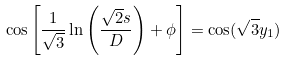Convert formula to latex. <formula><loc_0><loc_0><loc_500><loc_500>\cos \left [ \frac { 1 } { \sqrt { 3 } } \ln \left ( \frac { \sqrt { 2 } s } { D } \right ) + \phi \right ] = \cos ( \sqrt { 3 } y _ { 1 } )</formula> 